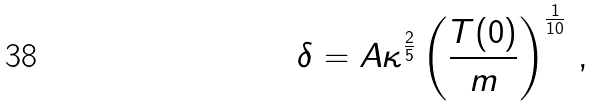<formula> <loc_0><loc_0><loc_500><loc_500>\delta = A \kappa ^ { \frac { 2 } { 5 } } \left ( \frac { T ( 0 ) } { m } \right ) ^ { \frac { 1 } { 1 0 } } \, ,</formula> 